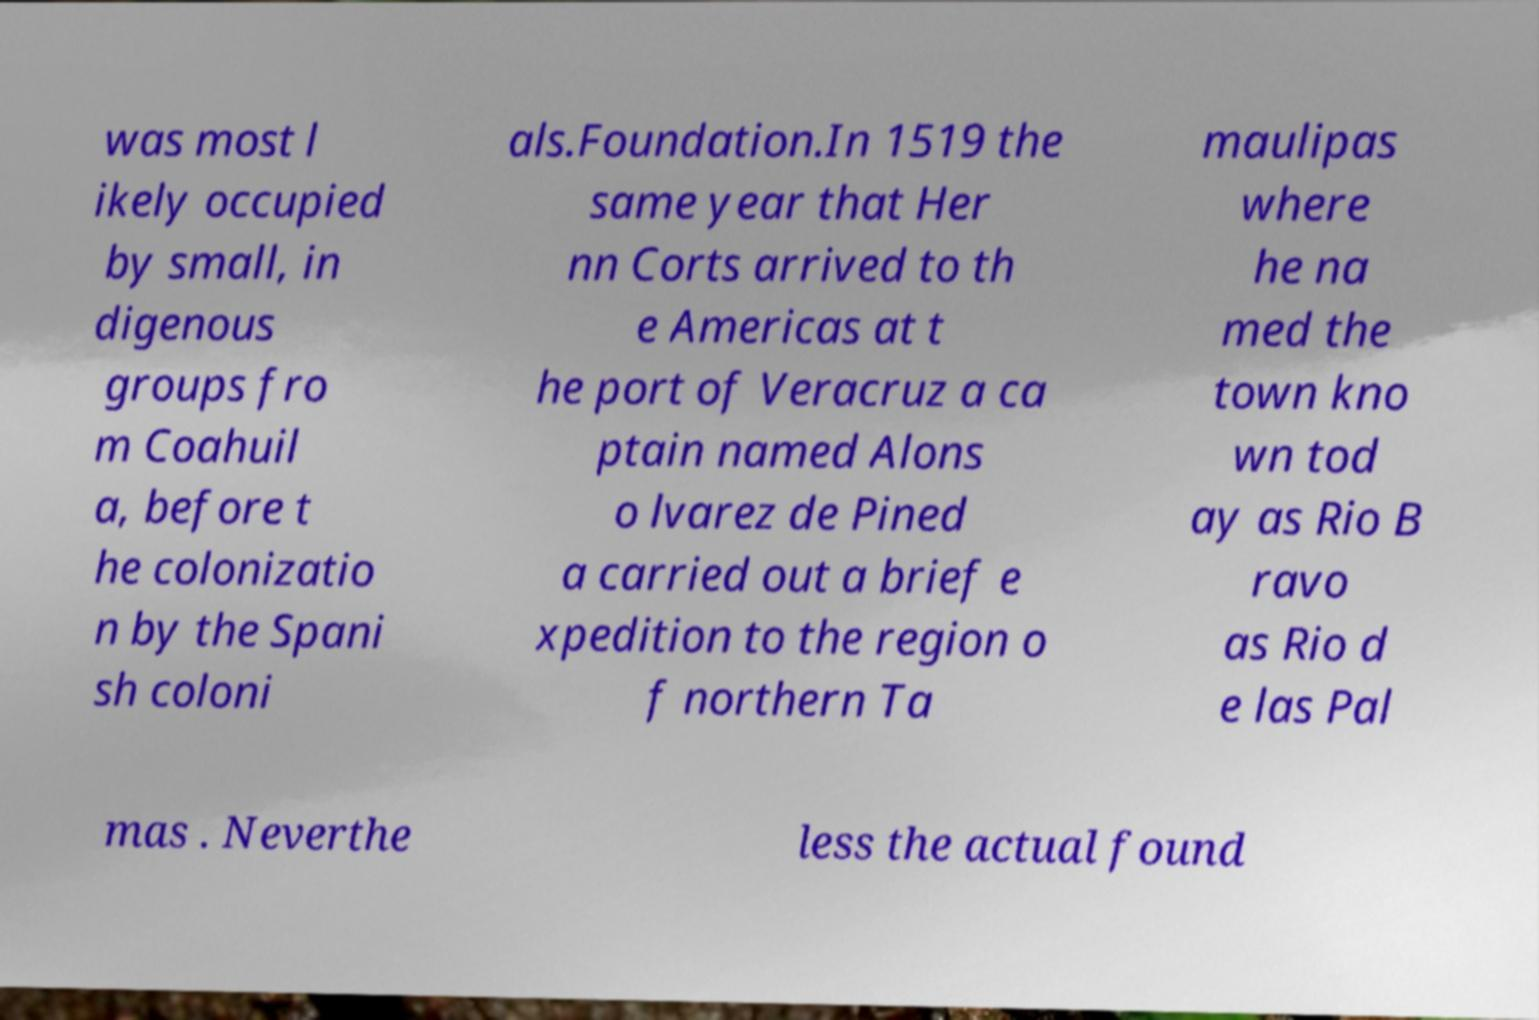Could you extract and type out the text from this image? was most l ikely occupied by small, in digenous groups fro m Coahuil a, before t he colonizatio n by the Spani sh coloni als.Foundation.In 1519 the same year that Her nn Corts arrived to th e Americas at t he port of Veracruz a ca ptain named Alons o lvarez de Pined a carried out a brief e xpedition to the region o f northern Ta maulipas where he na med the town kno wn tod ay as Rio B ravo as Rio d e las Pal mas . Neverthe less the actual found 